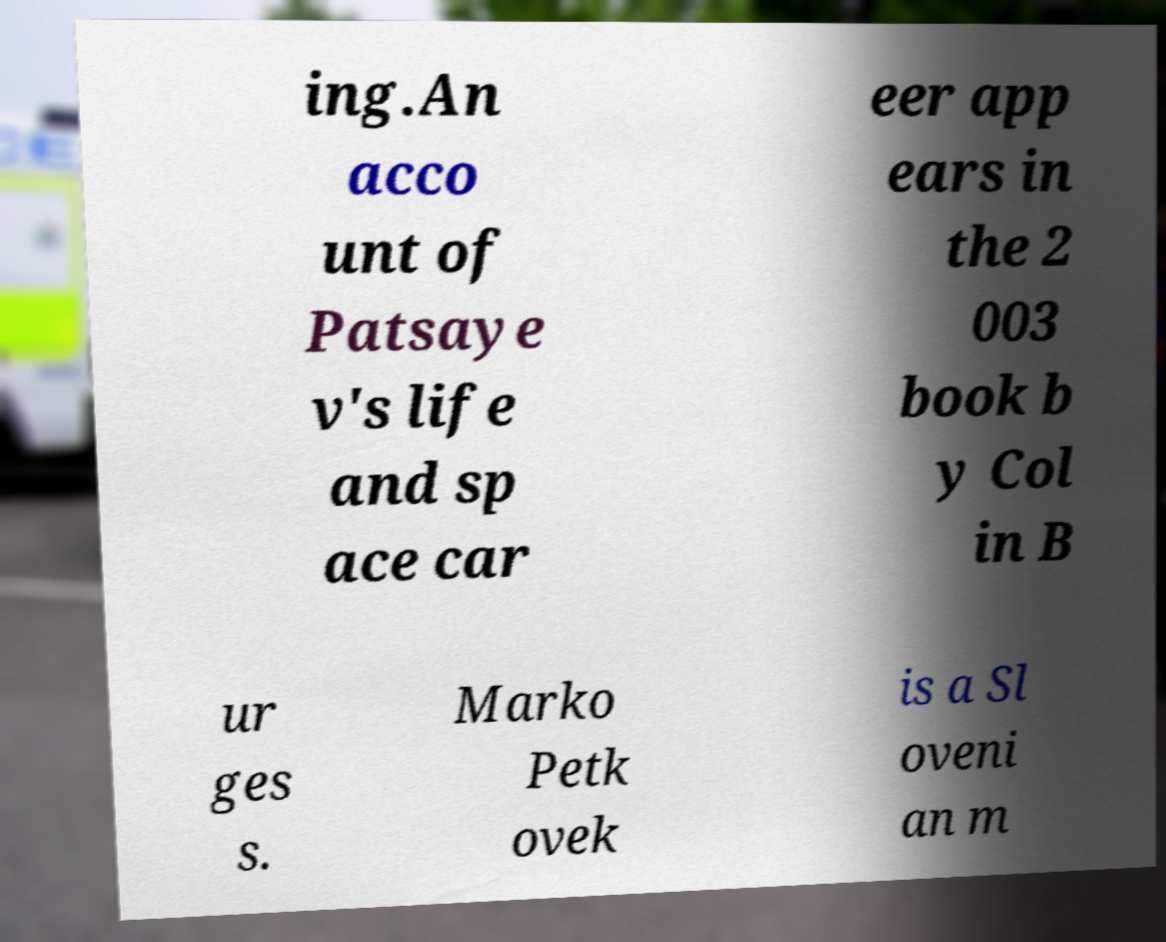Could you assist in decoding the text presented in this image and type it out clearly? ing.An acco unt of Patsaye v's life and sp ace car eer app ears in the 2 003 book b y Col in B ur ges s. Marko Petk ovek is a Sl oveni an m 